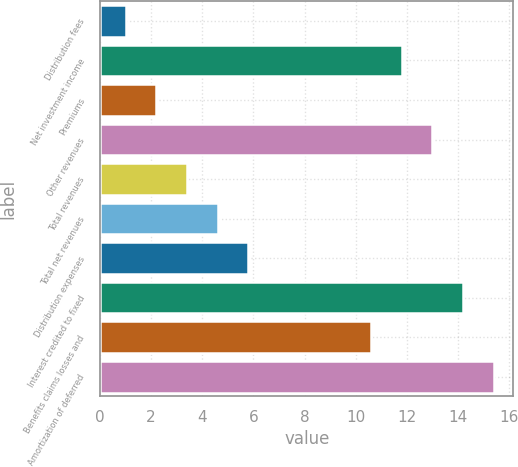Convert chart to OTSL. <chart><loc_0><loc_0><loc_500><loc_500><bar_chart><fcel>Distribution fees<fcel>Net investment income<fcel>Premiums<fcel>Other revenues<fcel>Total revenues<fcel>Total net revenues<fcel>Distribution expenses<fcel>Interest credited to fixed<fcel>Benefits claims losses and<fcel>Amortization of deferred<nl><fcel>1<fcel>11.8<fcel>2.2<fcel>13<fcel>3.4<fcel>4.6<fcel>5.8<fcel>14.2<fcel>10.6<fcel>15.4<nl></chart> 